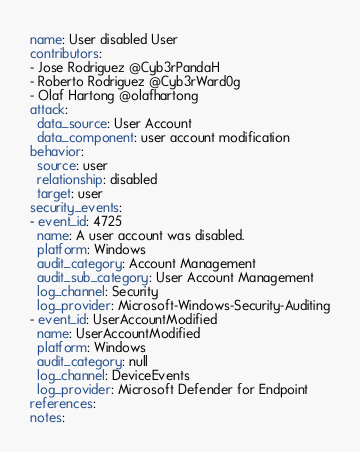<code> <loc_0><loc_0><loc_500><loc_500><_YAML_>name: User disabled User
contributors:
- Jose Rodriguez @Cyb3rPandaH
- Roberto Rodriguez @Cyb3rWard0g
- Olaf Hartong @olafhartong
attack:
  data_source: User Account
  data_component: user account modification
behavior:
  source: user
  relationship: disabled
  target: user
security_events:
- event_id: 4725
  name: A user account was disabled.
  platform: Windows
  audit_category: Account Management
  audit_sub_category: User Account Management
  log_channel: Security
  log_provider: Microsoft-Windows-Security-Auditing
- event_id: UserAccountModified
  name: UserAccountModified
  platform: Windows
  audit_category: null
  log_channel: DeviceEvents
  log_provider: Microsoft Defender for Endpoint
references:
notes:</code> 